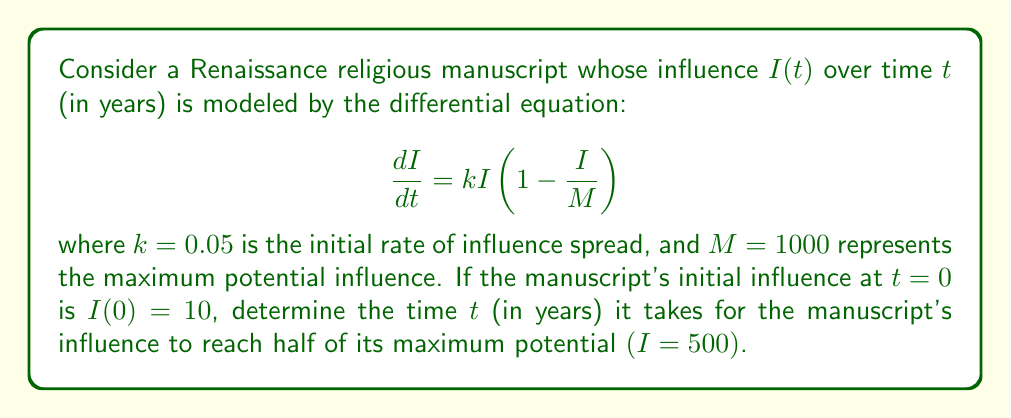Can you solve this math problem? To solve this problem, we need to use the logistic growth model, which is represented by the given differential equation. This model is particularly relevant for studying the spread of ideas or cultural influence over time.

1) First, we need to solve the differential equation. The solution to the logistic equation is:

   $$I(t) = \frac{M}{1 + (\frac{M}{I_0} - 1)e^{-kt}}$$

   where $I_0$ is the initial influence.

2) We're given that $M=1000$, $k=0.05$, and $I_0=10$. Let's substitute these values:

   $$I(t) = \frac{1000}{1 + (100 - 1)e^{-0.05t}}$$

3) We want to find $t$ when $I(t) = 500$ (half of the maximum influence). Let's set up the equation:

   $$500 = \frac{1000}{1 + 99e^{-0.05t}}$$

4) Now, let's solve for $t$:
   
   $$\frac{1000}{500} = 1 + 99e^{-0.05t}$$
   $$2 = 1 + 99e^{-0.05t}$$
   $$1 = 99e^{-0.05t}$$
   $$\frac{1}{99} = e^{-0.05t}$$

5) Taking the natural logarithm of both sides:

   $$\ln(\frac{1}{99}) = -0.05t$$
   $$-\ln(99) = -0.05t$$

6) Solving for $t$:

   $$t = \frac{\ln(99)}{0.05} \approx 92.1$$

Therefore, it takes approximately 92.1 years for the manuscript's influence to reach half of its maximum potential.
Answer: $t \approx 92.1$ years 